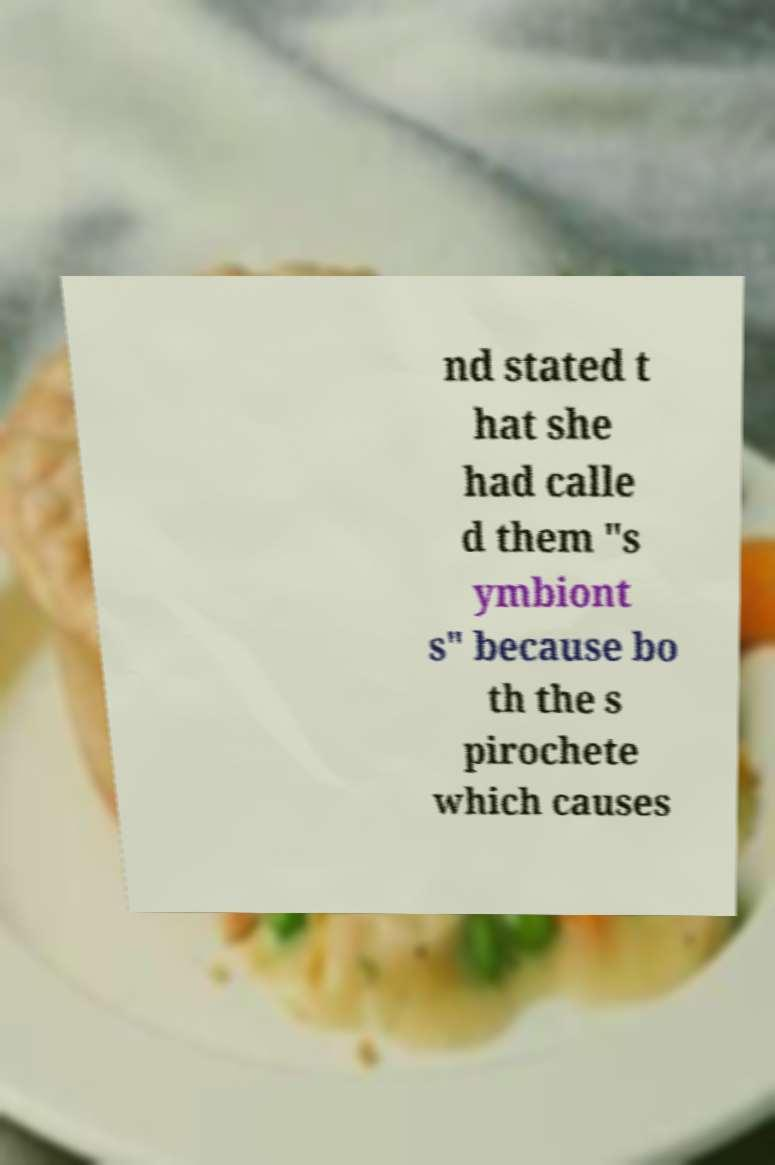Please identify and transcribe the text found in this image. nd stated t hat she had calle d them "s ymbiont s" because bo th the s pirochete which causes 